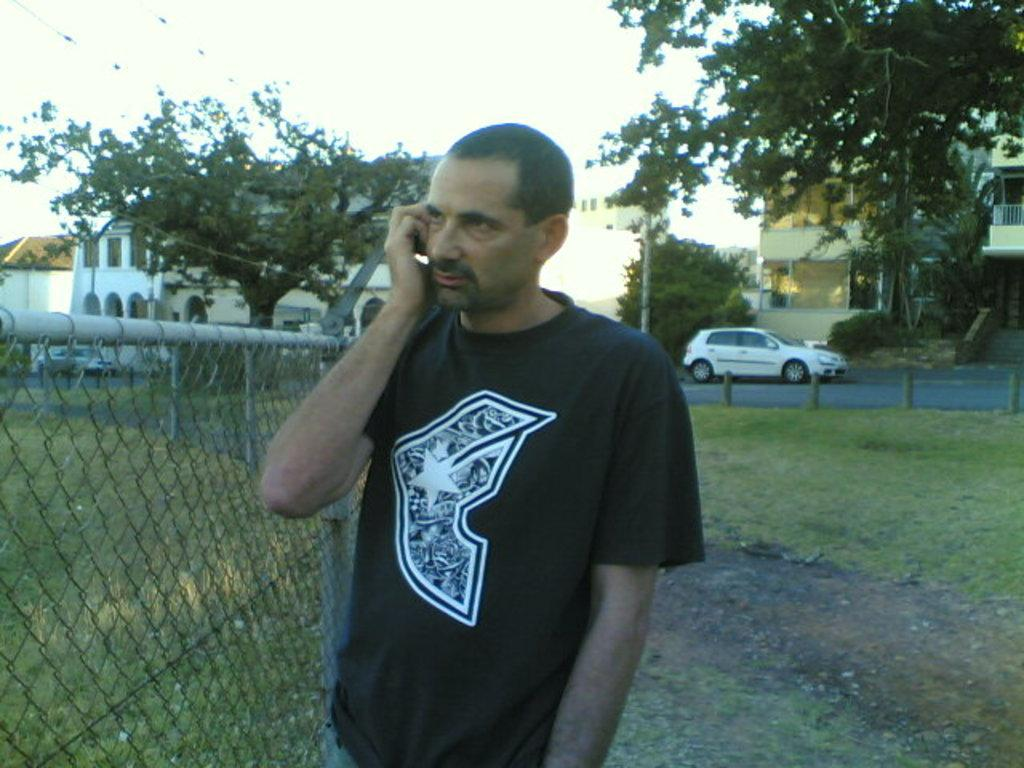What is the main subject of the image? There is a person standing in the image. What can be seen in the background of the image? The sky is visible in the background of the image. What type of structures are present in the image? There are houses in the image. What else can be seen in the image besides the person and houses? There is a wire fence and trees in the image. Are there any vehicles visible in the image? Yes, there are vehicles on the road in the image. What type of surprise can be seen in the person's hand in the image? There is no surprise visible in the person's hand in the image. What does the person need to do in order to enter the scene? The person is already in the scene, so there is no need for them to enter. 